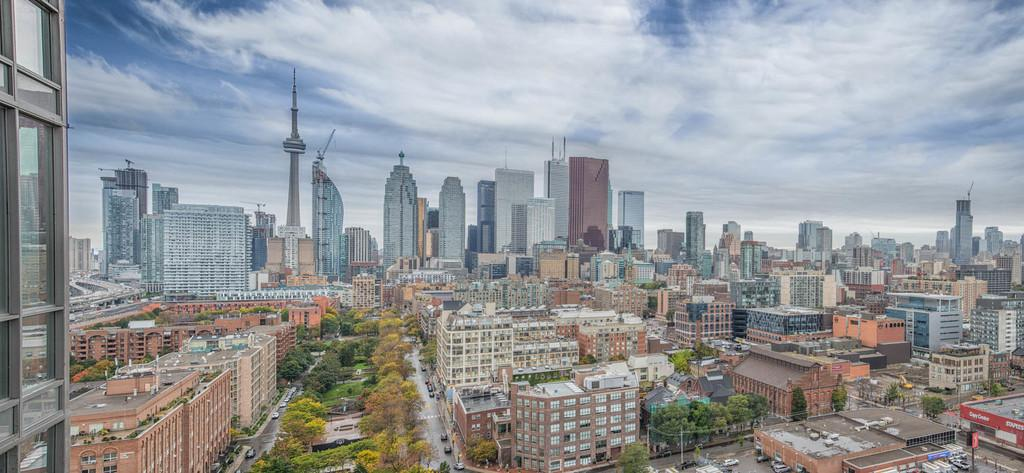What can be seen in the foreground of the image? There are many buildings, trees, and vehicles moving on the road in the foreground of the image. What is visible in the background of the image? The sky is visible at the top of the image. What can be observed in the sky? Clouds are present in the sky. What type of test is being conducted on the pipe in the image? There is no pipe present in the image, and therefore no test is being conducted. How does the pipe move around in the image? There is no pipe present in the image, so it cannot move around. 